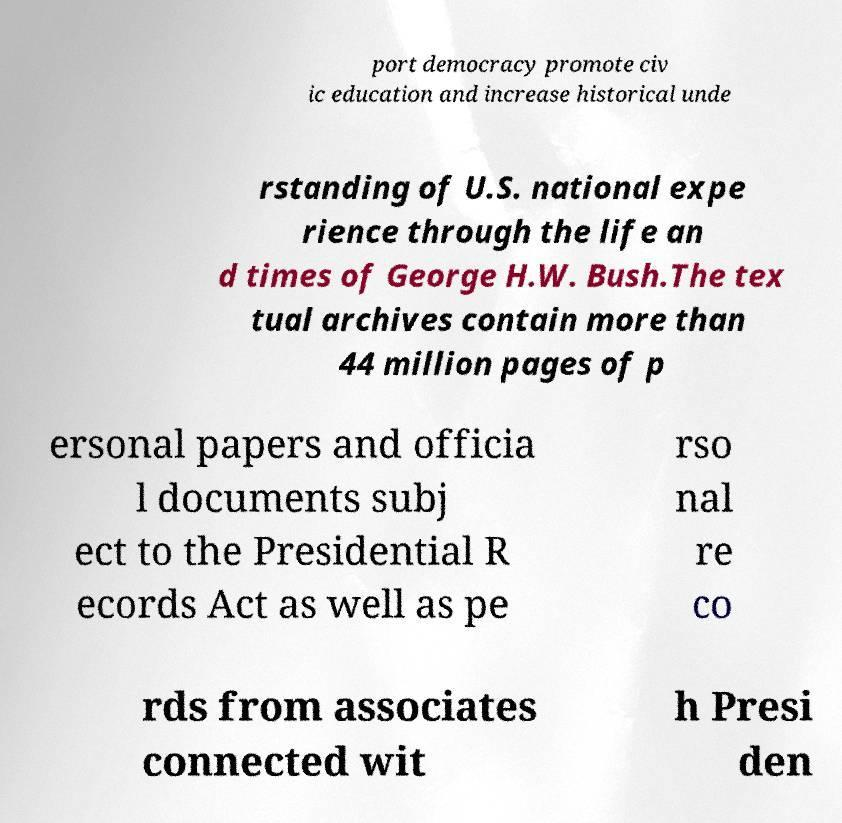What messages or text are displayed in this image? I need them in a readable, typed format. port democracy promote civ ic education and increase historical unde rstanding of U.S. national expe rience through the life an d times of George H.W. Bush.The tex tual archives contain more than 44 million pages of p ersonal papers and officia l documents subj ect to the Presidential R ecords Act as well as pe rso nal re co rds from associates connected wit h Presi den 